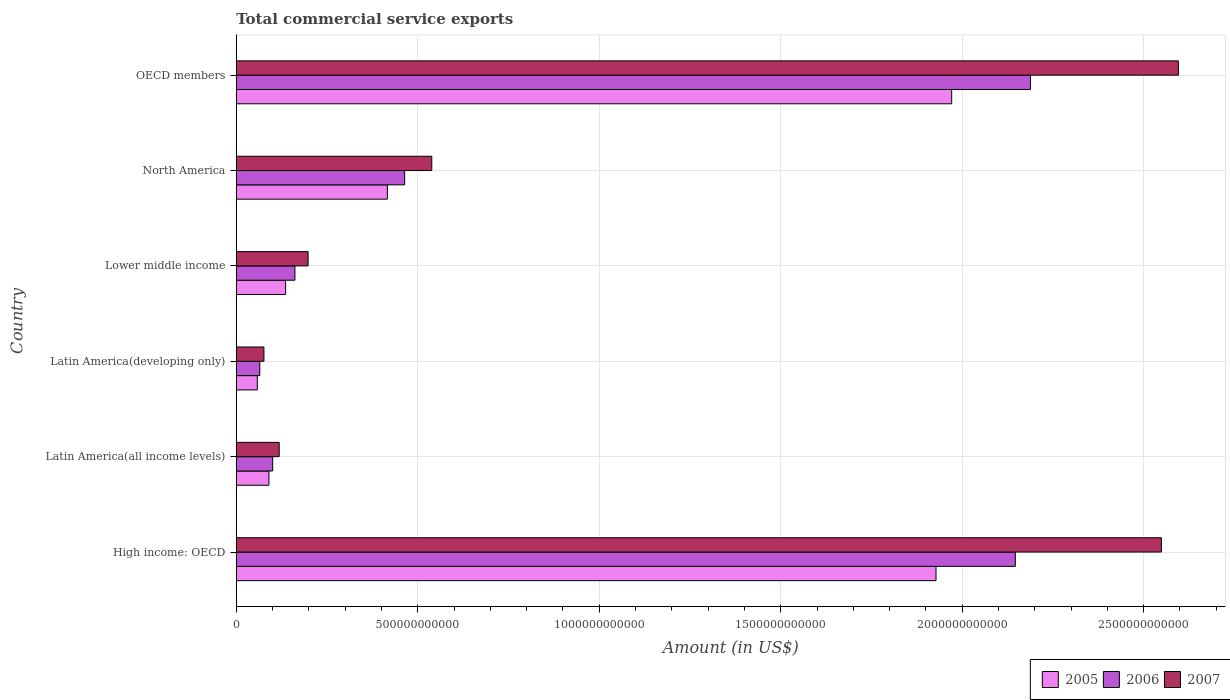Are the number of bars on each tick of the Y-axis equal?
Your answer should be compact. Yes. What is the label of the 6th group of bars from the top?
Keep it short and to the point. High income: OECD. What is the total commercial service exports in 2007 in Latin America(all income levels)?
Provide a short and direct response. 1.18e+11. Across all countries, what is the maximum total commercial service exports in 2007?
Your answer should be very brief. 2.60e+12. Across all countries, what is the minimum total commercial service exports in 2005?
Ensure brevity in your answer.  5.80e+1. In which country was the total commercial service exports in 2006 minimum?
Make the answer very short. Latin America(developing only). What is the total total commercial service exports in 2007 in the graph?
Ensure brevity in your answer.  6.08e+12. What is the difference between the total commercial service exports in 2006 in High income: OECD and that in North America?
Provide a succinct answer. 1.68e+12. What is the difference between the total commercial service exports in 2006 in Lower middle income and the total commercial service exports in 2005 in Latin America(developing only)?
Offer a very short reply. 1.04e+11. What is the average total commercial service exports in 2007 per country?
Provide a short and direct response. 1.01e+12. What is the difference between the total commercial service exports in 2006 and total commercial service exports in 2005 in North America?
Your answer should be very brief. 4.76e+1. What is the ratio of the total commercial service exports in 2005 in High income: OECD to that in OECD members?
Make the answer very short. 0.98. Is the total commercial service exports in 2007 in North America less than that in OECD members?
Ensure brevity in your answer.  Yes. What is the difference between the highest and the second highest total commercial service exports in 2007?
Your response must be concise. 4.68e+1. What is the difference between the highest and the lowest total commercial service exports in 2005?
Your answer should be compact. 1.91e+12. In how many countries, is the total commercial service exports in 2005 greater than the average total commercial service exports in 2005 taken over all countries?
Offer a very short reply. 2. What does the 3rd bar from the top in Lower middle income represents?
Your answer should be very brief. 2005. What does the 2nd bar from the bottom in Latin America(developing only) represents?
Keep it short and to the point. 2006. Is it the case that in every country, the sum of the total commercial service exports in 2007 and total commercial service exports in 2006 is greater than the total commercial service exports in 2005?
Make the answer very short. Yes. How many bars are there?
Provide a succinct answer. 18. What is the difference between two consecutive major ticks on the X-axis?
Provide a short and direct response. 5.00e+11. Are the values on the major ticks of X-axis written in scientific E-notation?
Your answer should be very brief. No. Does the graph contain any zero values?
Make the answer very short. No. Does the graph contain grids?
Make the answer very short. Yes. Where does the legend appear in the graph?
Your answer should be very brief. Bottom right. How many legend labels are there?
Offer a terse response. 3. How are the legend labels stacked?
Offer a terse response. Horizontal. What is the title of the graph?
Give a very brief answer. Total commercial service exports. Does "1991" appear as one of the legend labels in the graph?
Provide a short and direct response. No. What is the label or title of the X-axis?
Ensure brevity in your answer.  Amount (in US$). What is the Amount (in US$) of 2005 in High income: OECD?
Provide a succinct answer. 1.93e+12. What is the Amount (in US$) in 2006 in High income: OECD?
Provide a succinct answer. 2.15e+12. What is the Amount (in US$) of 2007 in High income: OECD?
Your answer should be very brief. 2.55e+12. What is the Amount (in US$) of 2005 in Latin America(all income levels)?
Your answer should be compact. 9.00e+1. What is the Amount (in US$) of 2006 in Latin America(all income levels)?
Give a very brief answer. 1.00e+11. What is the Amount (in US$) of 2007 in Latin America(all income levels)?
Offer a terse response. 1.18e+11. What is the Amount (in US$) of 2005 in Latin America(developing only)?
Ensure brevity in your answer.  5.80e+1. What is the Amount (in US$) in 2006 in Latin America(developing only)?
Your answer should be very brief. 6.49e+1. What is the Amount (in US$) of 2007 in Latin America(developing only)?
Your answer should be very brief. 7.63e+1. What is the Amount (in US$) in 2005 in Lower middle income?
Provide a short and direct response. 1.36e+11. What is the Amount (in US$) in 2006 in Lower middle income?
Provide a succinct answer. 1.62e+11. What is the Amount (in US$) of 2007 in Lower middle income?
Your response must be concise. 1.98e+11. What is the Amount (in US$) in 2005 in North America?
Your answer should be very brief. 4.16e+11. What is the Amount (in US$) in 2006 in North America?
Keep it short and to the point. 4.64e+11. What is the Amount (in US$) in 2007 in North America?
Keep it short and to the point. 5.39e+11. What is the Amount (in US$) of 2005 in OECD members?
Your answer should be very brief. 1.97e+12. What is the Amount (in US$) in 2006 in OECD members?
Make the answer very short. 2.19e+12. What is the Amount (in US$) in 2007 in OECD members?
Keep it short and to the point. 2.60e+12. Across all countries, what is the maximum Amount (in US$) in 2005?
Offer a very short reply. 1.97e+12. Across all countries, what is the maximum Amount (in US$) of 2006?
Offer a terse response. 2.19e+12. Across all countries, what is the maximum Amount (in US$) in 2007?
Your answer should be compact. 2.60e+12. Across all countries, what is the minimum Amount (in US$) of 2005?
Offer a very short reply. 5.80e+1. Across all countries, what is the minimum Amount (in US$) of 2006?
Make the answer very short. 6.49e+1. Across all countries, what is the minimum Amount (in US$) in 2007?
Your answer should be compact. 7.63e+1. What is the total Amount (in US$) in 2005 in the graph?
Keep it short and to the point. 4.60e+12. What is the total Amount (in US$) in 2006 in the graph?
Offer a terse response. 5.13e+12. What is the total Amount (in US$) of 2007 in the graph?
Your response must be concise. 6.08e+12. What is the difference between the Amount (in US$) in 2005 in High income: OECD and that in Latin America(all income levels)?
Offer a terse response. 1.84e+12. What is the difference between the Amount (in US$) in 2006 in High income: OECD and that in Latin America(all income levels)?
Ensure brevity in your answer.  2.05e+12. What is the difference between the Amount (in US$) of 2007 in High income: OECD and that in Latin America(all income levels)?
Provide a succinct answer. 2.43e+12. What is the difference between the Amount (in US$) in 2005 in High income: OECD and that in Latin America(developing only)?
Offer a very short reply. 1.87e+12. What is the difference between the Amount (in US$) in 2006 in High income: OECD and that in Latin America(developing only)?
Give a very brief answer. 2.08e+12. What is the difference between the Amount (in US$) in 2007 in High income: OECD and that in Latin America(developing only)?
Give a very brief answer. 2.47e+12. What is the difference between the Amount (in US$) in 2005 in High income: OECD and that in Lower middle income?
Your answer should be compact. 1.79e+12. What is the difference between the Amount (in US$) in 2006 in High income: OECD and that in Lower middle income?
Provide a succinct answer. 1.98e+12. What is the difference between the Amount (in US$) of 2007 in High income: OECD and that in Lower middle income?
Provide a succinct answer. 2.35e+12. What is the difference between the Amount (in US$) of 2005 in High income: OECD and that in North America?
Provide a succinct answer. 1.51e+12. What is the difference between the Amount (in US$) in 2006 in High income: OECD and that in North America?
Your response must be concise. 1.68e+12. What is the difference between the Amount (in US$) of 2007 in High income: OECD and that in North America?
Ensure brevity in your answer.  2.01e+12. What is the difference between the Amount (in US$) of 2005 in High income: OECD and that in OECD members?
Make the answer very short. -4.32e+1. What is the difference between the Amount (in US$) in 2006 in High income: OECD and that in OECD members?
Offer a very short reply. -4.16e+1. What is the difference between the Amount (in US$) in 2007 in High income: OECD and that in OECD members?
Your answer should be very brief. -4.68e+1. What is the difference between the Amount (in US$) in 2005 in Latin America(all income levels) and that in Latin America(developing only)?
Your answer should be very brief. 3.20e+1. What is the difference between the Amount (in US$) of 2006 in Latin America(all income levels) and that in Latin America(developing only)?
Offer a very short reply. 3.54e+1. What is the difference between the Amount (in US$) in 2007 in Latin America(all income levels) and that in Latin America(developing only)?
Ensure brevity in your answer.  4.20e+1. What is the difference between the Amount (in US$) in 2005 in Latin America(all income levels) and that in Lower middle income?
Offer a terse response. -4.60e+1. What is the difference between the Amount (in US$) of 2006 in Latin America(all income levels) and that in Lower middle income?
Give a very brief answer. -6.13e+1. What is the difference between the Amount (in US$) of 2007 in Latin America(all income levels) and that in Lower middle income?
Your answer should be compact. -7.96e+1. What is the difference between the Amount (in US$) in 2005 in Latin America(all income levels) and that in North America?
Your answer should be compact. -3.26e+11. What is the difference between the Amount (in US$) of 2006 in Latin America(all income levels) and that in North America?
Your answer should be very brief. -3.64e+11. What is the difference between the Amount (in US$) of 2007 in Latin America(all income levels) and that in North America?
Offer a terse response. -4.20e+11. What is the difference between the Amount (in US$) of 2005 in Latin America(all income levels) and that in OECD members?
Give a very brief answer. -1.88e+12. What is the difference between the Amount (in US$) of 2006 in Latin America(all income levels) and that in OECD members?
Provide a succinct answer. -2.09e+12. What is the difference between the Amount (in US$) of 2007 in Latin America(all income levels) and that in OECD members?
Your response must be concise. -2.48e+12. What is the difference between the Amount (in US$) of 2005 in Latin America(developing only) and that in Lower middle income?
Your answer should be compact. -7.80e+1. What is the difference between the Amount (in US$) in 2006 in Latin America(developing only) and that in Lower middle income?
Make the answer very short. -9.68e+1. What is the difference between the Amount (in US$) in 2007 in Latin America(developing only) and that in Lower middle income?
Offer a terse response. -1.22e+11. What is the difference between the Amount (in US$) of 2005 in Latin America(developing only) and that in North America?
Offer a terse response. -3.58e+11. What is the difference between the Amount (in US$) in 2006 in Latin America(developing only) and that in North America?
Your answer should be compact. -3.99e+11. What is the difference between the Amount (in US$) of 2007 in Latin America(developing only) and that in North America?
Make the answer very short. -4.62e+11. What is the difference between the Amount (in US$) in 2005 in Latin America(developing only) and that in OECD members?
Your response must be concise. -1.91e+12. What is the difference between the Amount (in US$) of 2006 in Latin America(developing only) and that in OECD members?
Ensure brevity in your answer.  -2.12e+12. What is the difference between the Amount (in US$) in 2007 in Latin America(developing only) and that in OECD members?
Make the answer very short. -2.52e+12. What is the difference between the Amount (in US$) in 2005 in Lower middle income and that in North America?
Your answer should be compact. -2.80e+11. What is the difference between the Amount (in US$) in 2006 in Lower middle income and that in North America?
Ensure brevity in your answer.  -3.02e+11. What is the difference between the Amount (in US$) of 2007 in Lower middle income and that in North America?
Keep it short and to the point. -3.41e+11. What is the difference between the Amount (in US$) in 2005 in Lower middle income and that in OECD members?
Offer a terse response. -1.84e+12. What is the difference between the Amount (in US$) of 2006 in Lower middle income and that in OECD members?
Your response must be concise. -2.03e+12. What is the difference between the Amount (in US$) in 2007 in Lower middle income and that in OECD members?
Ensure brevity in your answer.  -2.40e+12. What is the difference between the Amount (in US$) of 2005 in North America and that in OECD members?
Offer a very short reply. -1.55e+12. What is the difference between the Amount (in US$) of 2006 in North America and that in OECD members?
Make the answer very short. -1.72e+12. What is the difference between the Amount (in US$) of 2007 in North America and that in OECD members?
Keep it short and to the point. -2.06e+12. What is the difference between the Amount (in US$) of 2005 in High income: OECD and the Amount (in US$) of 2006 in Latin America(all income levels)?
Your answer should be compact. 1.83e+12. What is the difference between the Amount (in US$) in 2005 in High income: OECD and the Amount (in US$) in 2007 in Latin America(all income levels)?
Offer a very short reply. 1.81e+12. What is the difference between the Amount (in US$) of 2006 in High income: OECD and the Amount (in US$) of 2007 in Latin America(all income levels)?
Your answer should be very brief. 2.03e+12. What is the difference between the Amount (in US$) of 2005 in High income: OECD and the Amount (in US$) of 2006 in Latin America(developing only)?
Provide a succinct answer. 1.86e+12. What is the difference between the Amount (in US$) of 2005 in High income: OECD and the Amount (in US$) of 2007 in Latin America(developing only)?
Keep it short and to the point. 1.85e+12. What is the difference between the Amount (in US$) of 2006 in High income: OECD and the Amount (in US$) of 2007 in Latin America(developing only)?
Offer a terse response. 2.07e+12. What is the difference between the Amount (in US$) in 2005 in High income: OECD and the Amount (in US$) in 2006 in Lower middle income?
Your answer should be compact. 1.77e+12. What is the difference between the Amount (in US$) of 2005 in High income: OECD and the Amount (in US$) of 2007 in Lower middle income?
Make the answer very short. 1.73e+12. What is the difference between the Amount (in US$) of 2006 in High income: OECD and the Amount (in US$) of 2007 in Lower middle income?
Make the answer very short. 1.95e+12. What is the difference between the Amount (in US$) of 2005 in High income: OECD and the Amount (in US$) of 2006 in North America?
Provide a short and direct response. 1.46e+12. What is the difference between the Amount (in US$) of 2005 in High income: OECD and the Amount (in US$) of 2007 in North America?
Make the answer very short. 1.39e+12. What is the difference between the Amount (in US$) in 2006 in High income: OECD and the Amount (in US$) in 2007 in North America?
Offer a very short reply. 1.61e+12. What is the difference between the Amount (in US$) of 2005 in High income: OECD and the Amount (in US$) of 2006 in OECD members?
Your answer should be very brief. -2.60e+11. What is the difference between the Amount (in US$) in 2005 in High income: OECD and the Amount (in US$) in 2007 in OECD members?
Make the answer very short. -6.68e+11. What is the difference between the Amount (in US$) of 2006 in High income: OECD and the Amount (in US$) of 2007 in OECD members?
Offer a very short reply. -4.49e+11. What is the difference between the Amount (in US$) in 2005 in Latin America(all income levels) and the Amount (in US$) in 2006 in Latin America(developing only)?
Your answer should be compact. 2.51e+1. What is the difference between the Amount (in US$) in 2005 in Latin America(all income levels) and the Amount (in US$) in 2007 in Latin America(developing only)?
Ensure brevity in your answer.  1.37e+1. What is the difference between the Amount (in US$) in 2006 in Latin America(all income levels) and the Amount (in US$) in 2007 in Latin America(developing only)?
Keep it short and to the point. 2.40e+1. What is the difference between the Amount (in US$) of 2005 in Latin America(all income levels) and the Amount (in US$) of 2006 in Lower middle income?
Provide a succinct answer. -7.16e+1. What is the difference between the Amount (in US$) of 2005 in Latin America(all income levels) and the Amount (in US$) of 2007 in Lower middle income?
Your answer should be very brief. -1.08e+11. What is the difference between the Amount (in US$) in 2006 in Latin America(all income levels) and the Amount (in US$) in 2007 in Lower middle income?
Make the answer very short. -9.75e+1. What is the difference between the Amount (in US$) of 2005 in Latin America(all income levels) and the Amount (in US$) of 2006 in North America?
Make the answer very short. -3.74e+11. What is the difference between the Amount (in US$) of 2005 in Latin America(all income levels) and the Amount (in US$) of 2007 in North America?
Provide a succinct answer. -4.49e+11. What is the difference between the Amount (in US$) of 2006 in Latin America(all income levels) and the Amount (in US$) of 2007 in North America?
Ensure brevity in your answer.  -4.38e+11. What is the difference between the Amount (in US$) of 2005 in Latin America(all income levels) and the Amount (in US$) of 2006 in OECD members?
Your answer should be compact. -2.10e+12. What is the difference between the Amount (in US$) in 2005 in Latin America(all income levels) and the Amount (in US$) in 2007 in OECD members?
Keep it short and to the point. -2.51e+12. What is the difference between the Amount (in US$) of 2006 in Latin America(all income levels) and the Amount (in US$) of 2007 in OECD members?
Make the answer very short. -2.50e+12. What is the difference between the Amount (in US$) of 2005 in Latin America(developing only) and the Amount (in US$) of 2006 in Lower middle income?
Offer a terse response. -1.04e+11. What is the difference between the Amount (in US$) in 2005 in Latin America(developing only) and the Amount (in US$) in 2007 in Lower middle income?
Your response must be concise. -1.40e+11. What is the difference between the Amount (in US$) of 2006 in Latin America(developing only) and the Amount (in US$) of 2007 in Lower middle income?
Provide a succinct answer. -1.33e+11. What is the difference between the Amount (in US$) in 2005 in Latin America(developing only) and the Amount (in US$) in 2006 in North America?
Provide a short and direct response. -4.06e+11. What is the difference between the Amount (in US$) in 2005 in Latin America(developing only) and the Amount (in US$) in 2007 in North America?
Provide a short and direct response. -4.81e+11. What is the difference between the Amount (in US$) of 2006 in Latin America(developing only) and the Amount (in US$) of 2007 in North America?
Give a very brief answer. -4.74e+11. What is the difference between the Amount (in US$) in 2005 in Latin America(developing only) and the Amount (in US$) in 2006 in OECD members?
Provide a short and direct response. -2.13e+12. What is the difference between the Amount (in US$) of 2005 in Latin America(developing only) and the Amount (in US$) of 2007 in OECD members?
Keep it short and to the point. -2.54e+12. What is the difference between the Amount (in US$) of 2006 in Latin America(developing only) and the Amount (in US$) of 2007 in OECD members?
Keep it short and to the point. -2.53e+12. What is the difference between the Amount (in US$) of 2005 in Lower middle income and the Amount (in US$) of 2006 in North America?
Provide a succinct answer. -3.28e+11. What is the difference between the Amount (in US$) in 2005 in Lower middle income and the Amount (in US$) in 2007 in North America?
Provide a short and direct response. -4.03e+11. What is the difference between the Amount (in US$) in 2006 in Lower middle income and the Amount (in US$) in 2007 in North America?
Offer a very short reply. -3.77e+11. What is the difference between the Amount (in US$) in 2005 in Lower middle income and the Amount (in US$) in 2006 in OECD members?
Offer a very short reply. -2.05e+12. What is the difference between the Amount (in US$) of 2005 in Lower middle income and the Amount (in US$) of 2007 in OECD members?
Give a very brief answer. -2.46e+12. What is the difference between the Amount (in US$) in 2006 in Lower middle income and the Amount (in US$) in 2007 in OECD members?
Your response must be concise. -2.43e+12. What is the difference between the Amount (in US$) in 2005 in North America and the Amount (in US$) in 2006 in OECD members?
Offer a very short reply. -1.77e+12. What is the difference between the Amount (in US$) in 2005 in North America and the Amount (in US$) in 2007 in OECD members?
Your answer should be compact. -2.18e+12. What is the difference between the Amount (in US$) of 2006 in North America and the Amount (in US$) of 2007 in OECD members?
Ensure brevity in your answer.  -2.13e+12. What is the average Amount (in US$) of 2005 per country?
Make the answer very short. 7.67e+11. What is the average Amount (in US$) of 2006 per country?
Make the answer very short. 8.54e+11. What is the average Amount (in US$) of 2007 per country?
Give a very brief answer. 1.01e+12. What is the difference between the Amount (in US$) of 2005 and Amount (in US$) of 2006 in High income: OECD?
Keep it short and to the point. -2.19e+11. What is the difference between the Amount (in US$) of 2005 and Amount (in US$) of 2007 in High income: OECD?
Provide a succinct answer. -6.21e+11. What is the difference between the Amount (in US$) of 2006 and Amount (in US$) of 2007 in High income: OECD?
Ensure brevity in your answer.  -4.02e+11. What is the difference between the Amount (in US$) of 2005 and Amount (in US$) of 2006 in Latin America(all income levels)?
Offer a very short reply. -1.03e+1. What is the difference between the Amount (in US$) of 2005 and Amount (in US$) of 2007 in Latin America(all income levels)?
Provide a short and direct response. -2.83e+1. What is the difference between the Amount (in US$) in 2006 and Amount (in US$) in 2007 in Latin America(all income levels)?
Give a very brief answer. -1.80e+1. What is the difference between the Amount (in US$) of 2005 and Amount (in US$) of 2006 in Latin America(developing only)?
Ensure brevity in your answer.  -6.88e+09. What is the difference between the Amount (in US$) of 2005 and Amount (in US$) of 2007 in Latin America(developing only)?
Keep it short and to the point. -1.83e+1. What is the difference between the Amount (in US$) of 2006 and Amount (in US$) of 2007 in Latin America(developing only)?
Keep it short and to the point. -1.14e+1. What is the difference between the Amount (in US$) in 2005 and Amount (in US$) in 2006 in Lower middle income?
Your response must be concise. -2.57e+1. What is the difference between the Amount (in US$) in 2005 and Amount (in US$) in 2007 in Lower middle income?
Provide a succinct answer. -6.19e+1. What is the difference between the Amount (in US$) of 2006 and Amount (in US$) of 2007 in Lower middle income?
Your response must be concise. -3.62e+1. What is the difference between the Amount (in US$) in 2005 and Amount (in US$) in 2006 in North America?
Your answer should be very brief. -4.76e+1. What is the difference between the Amount (in US$) of 2005 and Amount (in US$) of 2007 in North America?
Give a very brief answer. -1.22e+11. What is the difference between the Amount (in US$) of 2006 and Amount (in US$) of 2007 in North America?
Offer a very short reply. -7.47e+1. What is the difference between the Amount (in US$) in 2005 and Amount (in US$) in 2006 in OECD members?
Your response must be concise. -2.17e+11. What is the difference between the Amount (in US$) in 2005 and Amount (in US$) in 2007 in OECD members?
Your answer should be compact. -6.25e+11. What is the difference between the Amount (in US$) in 2006 and Amount (in US$) in 2007 in OECD members?
Ensure brevity in your answer.  -4.08e+11. What is the ratio of the Amount (in US$) of 2005 in High income: OECD to that in Latin America(all income levels)?
Your response must be concise. 21.42. What is the ratio of the Amount (in US$) of 2006 in High income: OECD to that in Latin America(all income levels)?
Your response must be concise. 21.39. What is the ratio of the Amount (in US$) of 2007 in High income: OECD to that in Latin America(all income levels)?
Make the answer very short. 21.54. What is the ratio of the Amount (in US$) in 2005 in High income: OECD to that in Latin America(developing only)?
Your answer should be very brief. 33.24. What is the ratio of the Amount (in US$) in 2006 in High income: OECD to that in Latin America(developing only)?
Your answer should be very brief. 33.08. What is the ratio of the Amount (in US$) of 2007 in High income: OECD to that in Latin America(developing only)?
Keep it short and to the point. 33.41. What is the ratio of the Amount (in US$) of 2005 in High income: OECD to that in Lower middle income?
Offer a terse response. 14.18. What is the ratio of the Amount (in US$) in 2006 in High income: OECD to that in Lower middle income?
Provide a short and direct response. 13.28. What is the ratio of the Amount (in US$) in 2007 in High income: OECD to that in Lower middle income?
Your response must be concise. 12.88. What is the ratio of the Amount (in US$) of 2005 in High income: OECD to that in North America?
Keep it short and to the point. 4.63. What is the ratio of the Amount (in US$) in 2006 in High income: OECD to that in North America?
Offer a terse response. 4.63. What is the ratio of the Amount (in US$) of 2007 in High income: OECD to that in North America?
Make the answer very short. 4.73. What is the ratio of the Amount (in US$) in 2005 in High income: OECD to that in OECD members?
Make the answer very short. 0.98. What is the ratio of the Amount (in US$) in 2007 in High income: OECD to that in OECD members?
Give a very brief answer. 0.98. What is the ratio of the Amount (in US$) in 2005 in Latin America(all income levels) to that in Latin America(developing only)?
Give a very brief answer. 1.55. What is the ratio of the Amount (in US$) in 2006 in Latin America(all income levels) to that in Latin America(developing only)?
Keep it short and to the point. 1.55. What is the ratio of the Amount (in US$) of 2007 in Latin America(all income levels) to that in Latin America(developing only)?
Offer a terse response. 1.55. What is the ratio of the Amount (in US$) of 2005 in Latin America(all income levels) to that in Lower middle income?
Provide a short and direct response. 0.66. What is the ratio of the Amount (in US$) of 2006 in Latin America(all income levels) to that in Lower middle income?
Give a very brief answer. 0.62. What is the ratio of the Amount (in US$) in 2007 in Latin America(all income levels) to that in Lower middle income?
Your answer should be very brief. 0.6. What is the ratio of the Amount (in US$) of 2005 in Latin America(all income levels) to that in North America?
Offer a terse response. 0.22. What is the ratio of the Amount (in US$) of 2006 in Latin America(all income levels) to that in North America?
Give a very brief answer. 0.22. What is the ratio of the Amount (in US$) of 2007 in Latin America(all income levels) to that in North America?
Provide a short and direct response. 0.22. What is the ratio of the Amount (in US$) in 2005 in Latin America(all income levels) to that in OECD members?
Give a very brief answer. 0.05. What is the ratio of the Amount (in US$) of 2006 in Latin America(all income levels) to that in OECD members?
Keep it short and to the point. 0.05. What is the ratio of the Amount (in US$) of 2007 in Latin America(all income levels) to that in OECD members?
Provide a short and direct response. 0.05. What is the ratio of the Amount (in US$) of 2005 in Latin America(developing only) to that in Lower middle income?
Give a very brief answer. 0.43. What is the ratio of the Amount (in US$) of 2006 in Latin America(developing only) to that in Lower middle income?
Provide a short and direct response. 0.4. What is the ratio of the Amount (in US$) of 2007 in Latin America(developing only) to that in Lower middle income?
Provide a succinct answer. 0.39. What is the ratio of the Amount (in US$) of 2005 in Latin America(developing only) to that in North America?
Provide a short and direct response. 0.14. What is the ratio of the Amount (in US$) of 2006 in Latin America(developing only) to that in North America?
Your answer should be compact. 0.14. What is the ratio of the Amount (in US$) in 2007 in Latin America(developing only) to that in North America?
Provide a short and direct response. 0.14. What is the ratio of the Amount (in US$) of 2005 in Latin America(developing only) to that in OECD members?
Ensure brevity in your answer.  0.03. What is the ratio of the Amount (in US$) in 2006 in Latin America(developing only) to that in OECD members?
Give a very brief answer. 0.03. What is the ratio of the Amount (in US$) of 2007 in Latin America(developing only) to that in OECD members?
Ensure brevity in your answer.  0.03. What is the ratio of the Amount (in US$) in 2005 in Lower middle income to that in North America?
Give a very brief answer. 0.33. What is the ratio of the Amount (in US$) of 2006 in Lower middle income to that in North America?
Your answer should be compact. 0.35. What is the ratio of the Amount (in US$) in 2007 in Lower middle income to that in North America?
Ensure brevity in your answer.  0.37. What is the ratio of the Amount (in US$) of 2005 in Lower middle income to that in OECD members?
Keep it short and to the point. 0.07. What is the ratio of the Amount (in US$) in 2006 in Lower middle income to that in OECD members?
Your answer should be very brief. 0.07. What is the ratio of the Amount (in US$) of 2007 in Lower middle income to that in OECD members?
Your answer should be compact. 0.08. What is the ratio of the Amount (in US$) in 2005 in North America to that in OECD members?
Offer a very short reply. 0.21. What is the ratio of the Amount (in US$) of 2006 in North America to that in OECD members?
Keep it short and to the point. 0.21. What is the ratio of the Amount (in US$) of 2007 in North America to that in OECD members?
Give a very brief answer. 0.21. What is the difference between the highest and the second highest Amount (in US$) of 2005?
Offer a very short reply. 4.32e+1. What is the difference between the highest and the second highest Amount (in US$) in 2006?
Provide a succinct answer. 4.16e+1. What is the difference between the highest and the second highest Amount (in US$) in 2007?
Your answer should be compact. 4.68e+1. What is the difference between the highest and the lowest Amount (in US$) in 2005?
Give a very brief answer. 1.91e+12. What is the difference between the highest and the lowest Amount (in US$) of 2006?
Offer a terse response. 2.12e+12. What is the difference between the highest and the lowest Amount (in US$) of 2007?
Provide a succinct answer. 2.52e+12. 